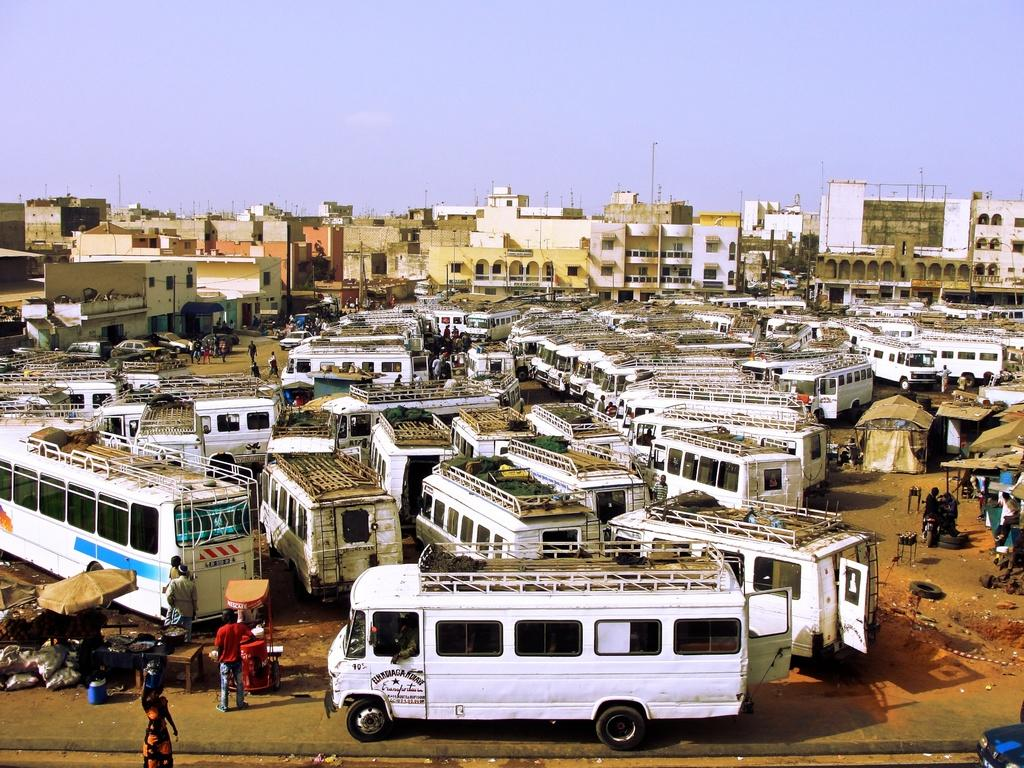What type of vehicles are present in the image? There are many buses in the image. What color are the buses? The buses are white in color. Where are the buses located? The buses are parked in a ground. What can be seen in the background of the image? There are buildings in the background of the image. What is visible at the top of the image? The sky is visible at the top of the image. What is present at the bottom of the image? There is a road at the bottom of the image. What behavior is exhibited by the buses in the image? The buses are parked and not exhibiting any behavior in the image. What is the cause of the buses being parked in the image? The cause of the buses being parked is not visible in the image, as it only shows the parked buses and not the reason for their parking. 